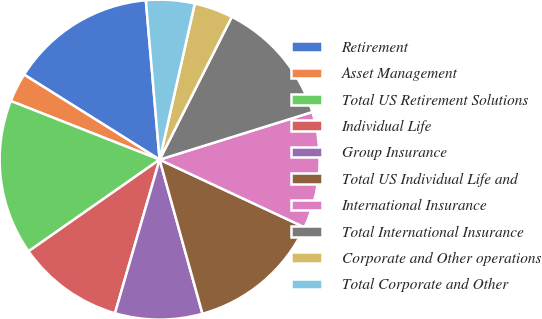<chart> <loc_0><loc_0><loc_500><loc_500><pie_chart><fcel>Retirement<fcel>Asset Management<fcel>Total US Retirement Solutions<fcel>Individual Life<fcel>Group Insurance<fcel>Total US Individual Life and<fcel>International Insurance<fcel>Total International Insurance<fcel>Corporate and Other operations<fcel>Total Corporate and Other<nl><fcel>14.71%<fcel>2.94%<fcel>15.69%<fcel>10.78%<fcel>8.82%<fcel>13.73%<fcel>11.76%<fcel>12.74%<fcel>3.92%<fcel>4.9%<nl></chart> 